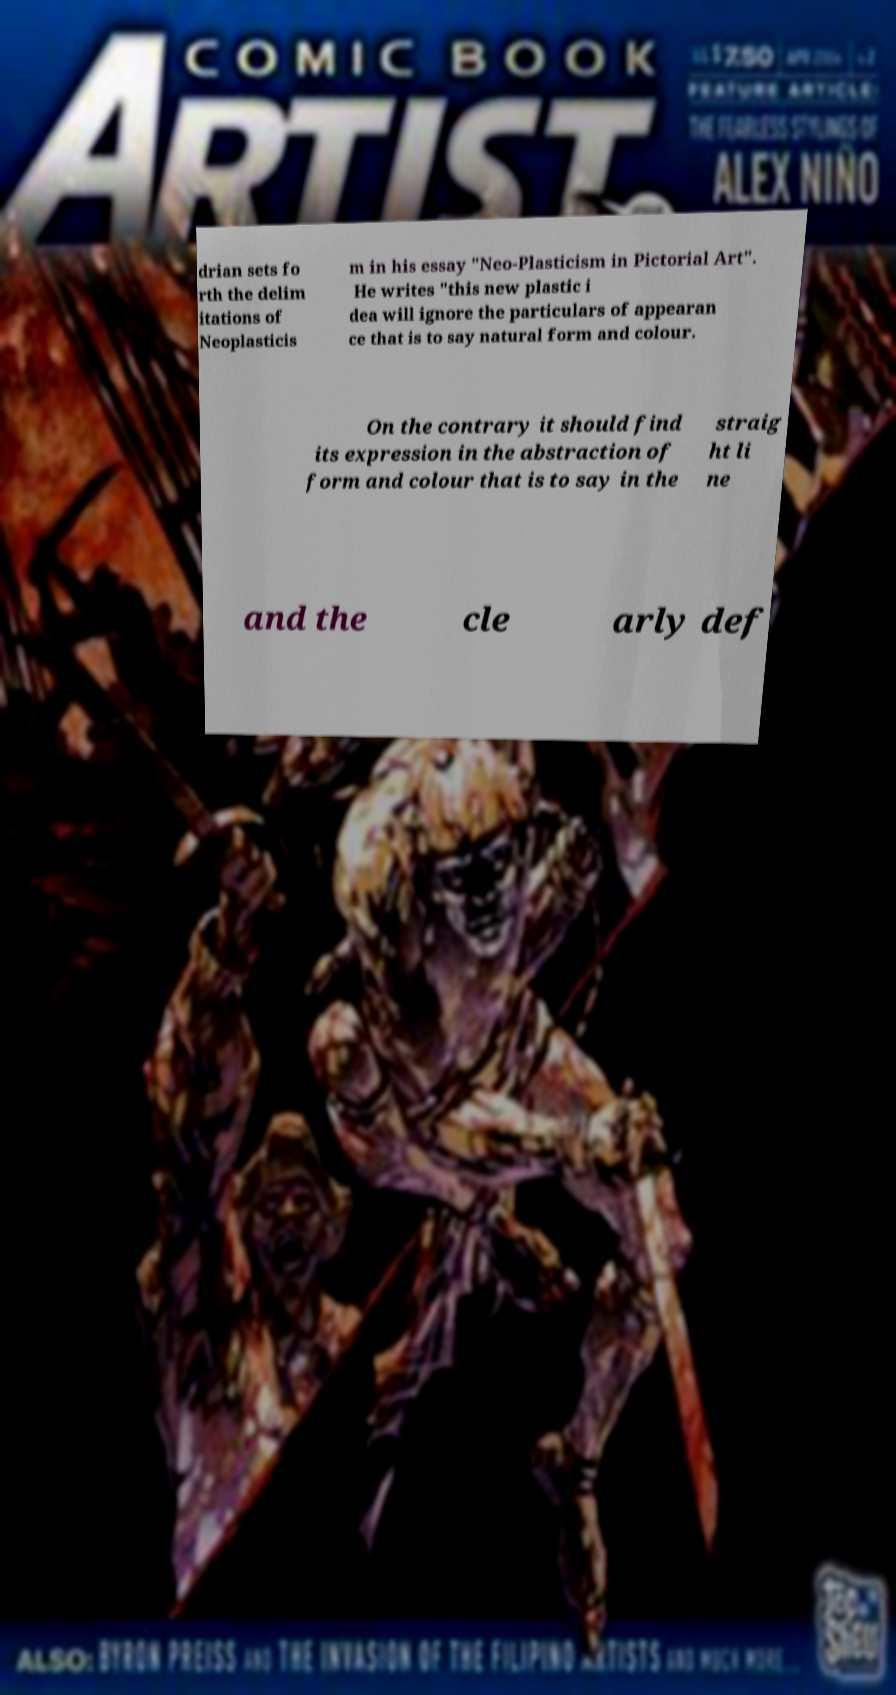For documentation purposes, I need the text within this image transcribed. Could you provide that? drian sets fo rth the delim itations of Neoplasticis m in his essay "Neo-Plasticism in Pictorial Art". He writes "this new plastic i dea will ignore the particulars of appearan ce that is to say natural form and colour. On the contrary it should find its expression in the abstraction of form and colour that is to say in the straig ht li ne and the cle arly def 